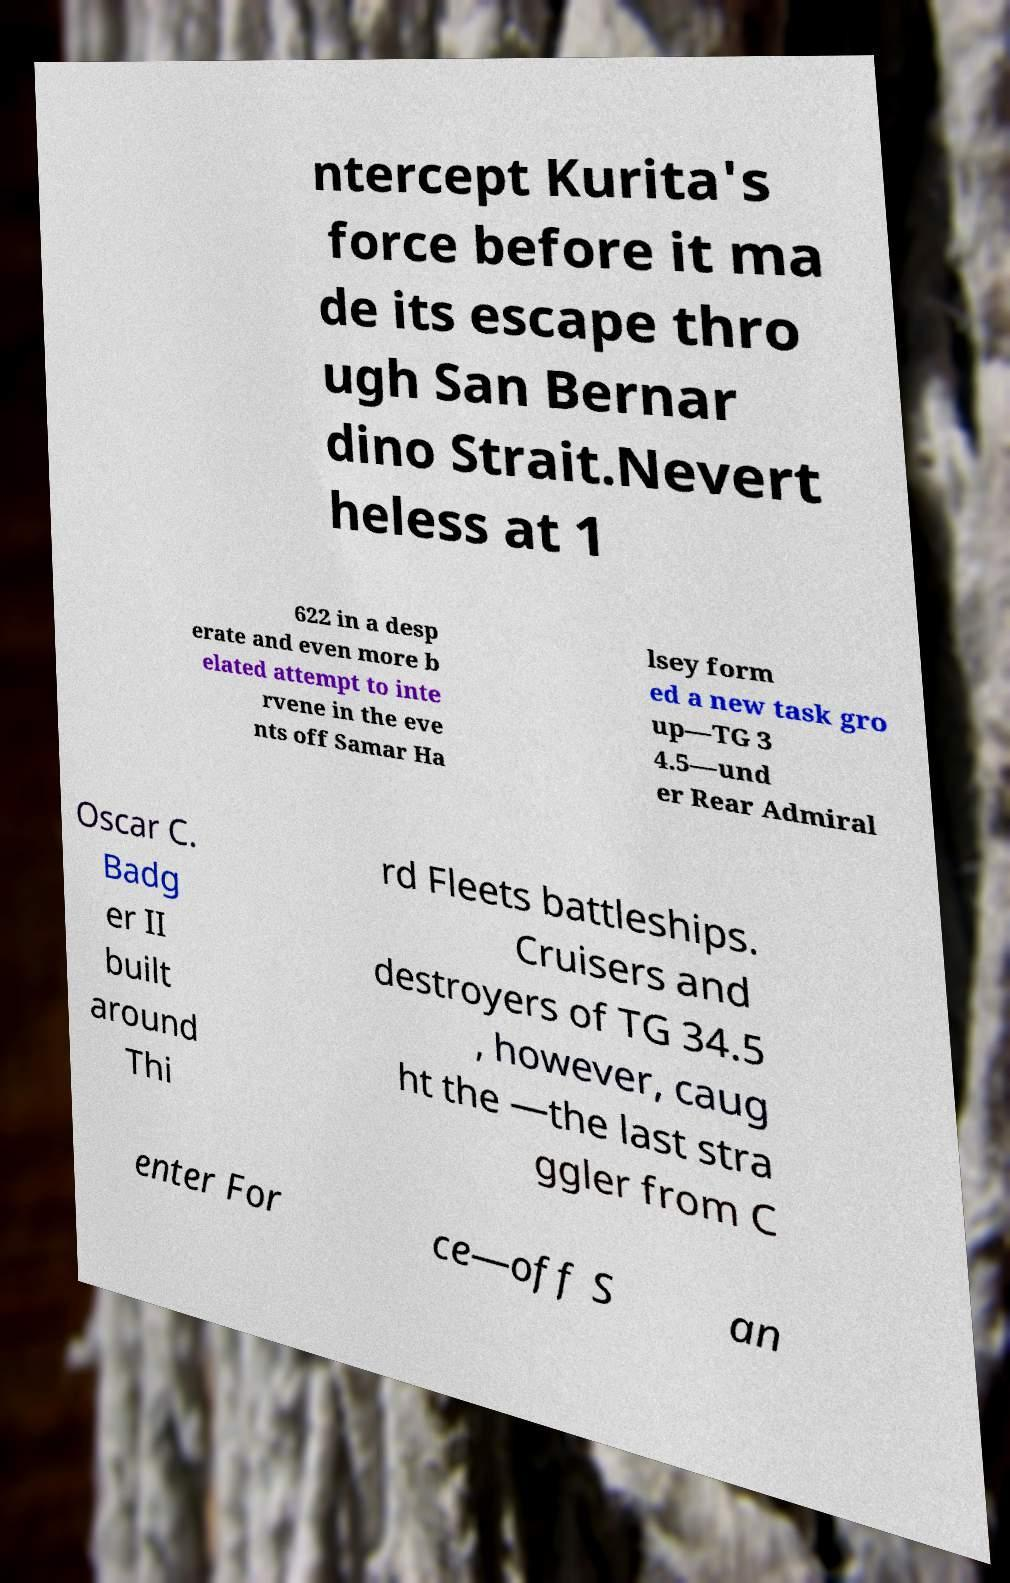Please identify and transcribe the text found in this image. ntercept Kurita's force before it ma de its escape thro ugh San Bernar dino Strait.Nevert heless at 1 622 in a desp erate and even more b elated attempt to inte rvene in the eve nts off Samar Ha lsey form ed a new task gro up—TG 3 4.5—und er Rear Admiral Oscar C. Badg er II built around Thi rd Fleets battleships. Cruisers and destroyers of TG 34.5 , however, caug ht the —the last stra ggler from C enter For ce—off S an 